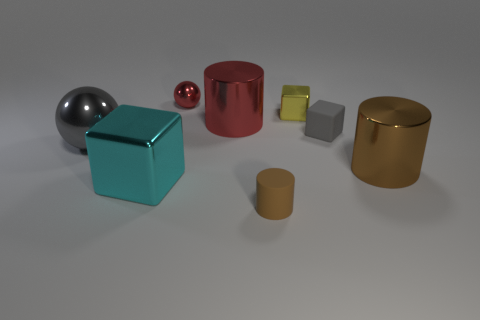What color is the metallic sphere that is left of the big metal block?
Give a very brief answer. Gray. Is the number of metal objects to the right of the large red shiny thing the same as the number of tiny shiny objects that are on the right side of the tiny red object?
Provide a succinct answer. No. What is the material of the gray block that is in front of the big red cylinder that is to the left of the gray rubber thing?
Your answer should be compact. Rubber. What number of objects are large metal objects or blocks that are to the right of the red cylinder?
Give a very brief answer. 6. There is a brown object that is the same material as the large red thing; what is its size?
Offer a terse response. Large. Is the number of small things on the left side of the small brown cylinder greater than the number of tiny brown metal spheres?
Ensure brevity in your answer.  Yes. How big is the cylinder that is in front of the large gray metal object and to the left of the yellow block?
Give a very brief answer. Small. There is another big object that is the same shape as the brown metal thing; what is it made of?
Make the answer very short. Metal. Do the cyan cube in front of the red metal cylinder and the large metal sphere have the same size?
Your answer should be compact. Yes. The big thing that is to the left of the large red cylinder and to the right of the gray sphere is what color?
Offer a terse response. Cyan. 